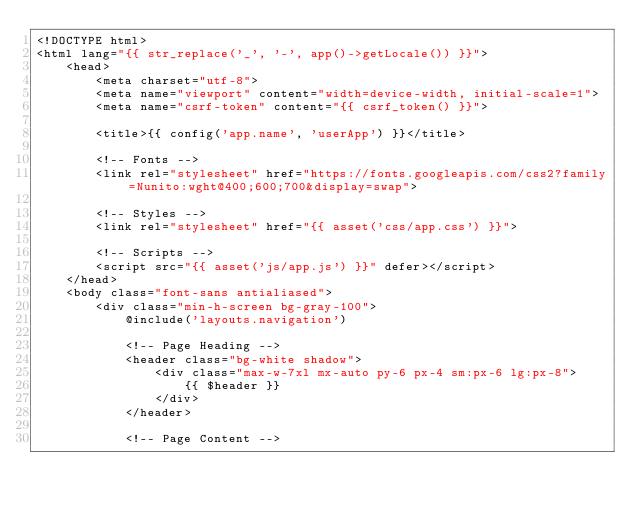<code> <loc_0><loc_0><loc_500><loc_500><_PHP_><!DOCTYPE html>
<html lang="{{ str_replace('_', '-', app()->getLocale()) }}">
    <head>
        <meta charset="utf-8">
        <meta name="viewport" content="width=device-width, initial-scale=1">
        <meta name="csrf-token" content="{{ csrf_token() }}">

        <title>{{ config('app.name', 'userApp') }}</title>

        <!-- Fonts -->
        <link rel="stylesheet" href="https://fonts.googleapis.com/css2?family=Nunito:wght@400;600;700&display=swap">

        <!-- Styles -->
        <link rel="stylesheet" href="{{ asset('css/app.css') }}">

        <!-- Scripts -->
        <script src="{{ asset('js/app.js') }}" defer></script>
    </head>
    <body class="font-sans antialiased">
        <div class="min-h-screen bg-gray-100">
            @include('layouts.navigation')

            <!-- Page Heading -->
            <header class="bg-white shadow">
                <div class="max-w-7xl mx-auto py-6 px-4 sm:px-6 lg:px-8">
                    {{ $header }}
                </div>
            </header>

            <!-- Page Content --></code> 